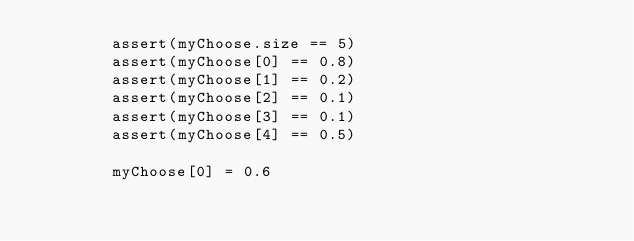Convert code to text. <code><loc_0><loc_0><loc_500><loc_500><_Kotlin_>        assert(myChoose.size == 5)
        assert(myChoose[0] == 0.8)
        assert(myChoose[1] == 0.2)
        assert(myChoose[2] == 0.1)
        assert(myChoose[3] == 0.1)
        assert(myChoose[4] == 0.5)

        myChoose[0] = 0.6</code> 